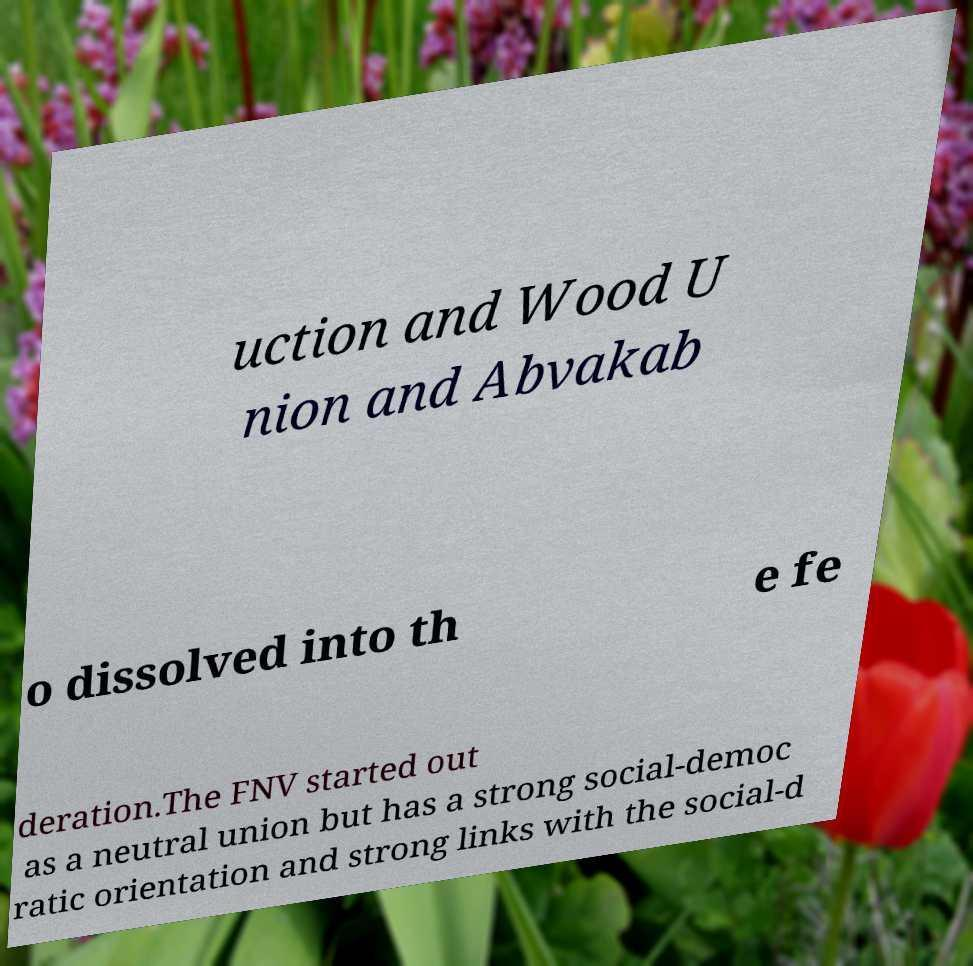Can you read and provide the text displayed in the image?This photo seems to have some interesting text. Can you extract and type it out for me? uction and Wood U nion and Abvakab o dissolved into th e fe deration.The FNV started out as a neutral union but has a strong social-democ ratic orientation and strong links with the social-d 